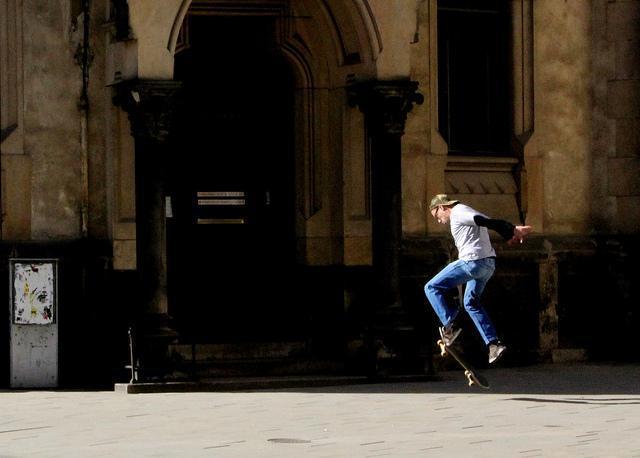How many adult birds are there?
Give a very brief answer. 0. 